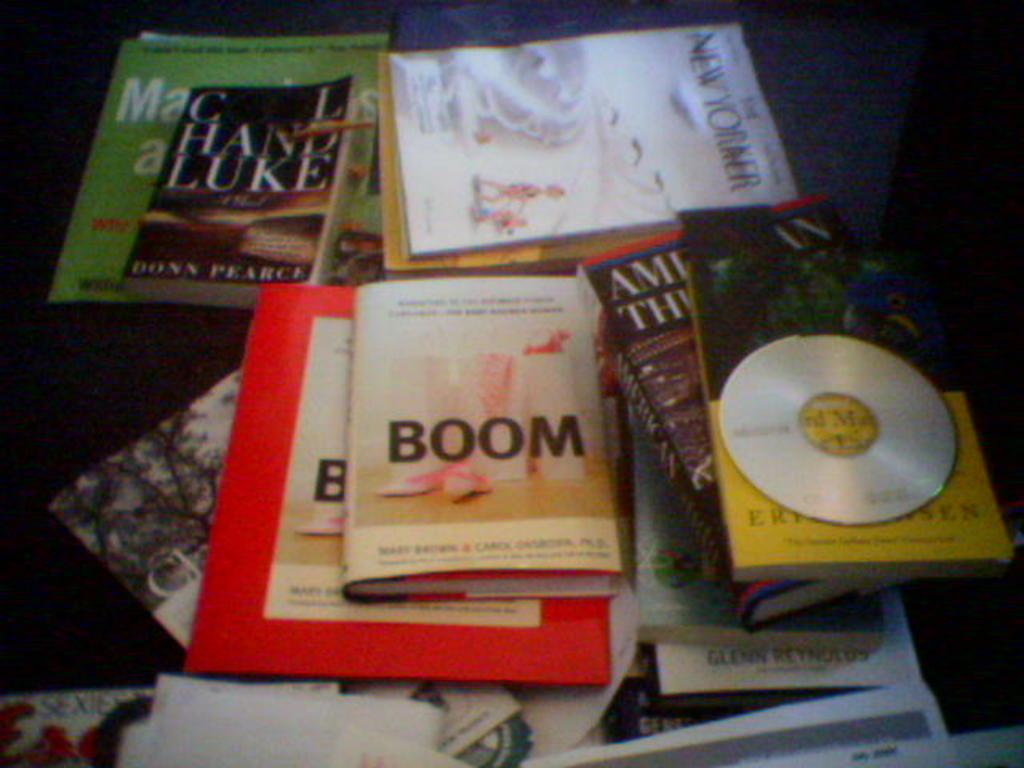<image>
Offer a succinct explanation of the picture presented. A book titled Boom lies on a table with other books and a CD. 